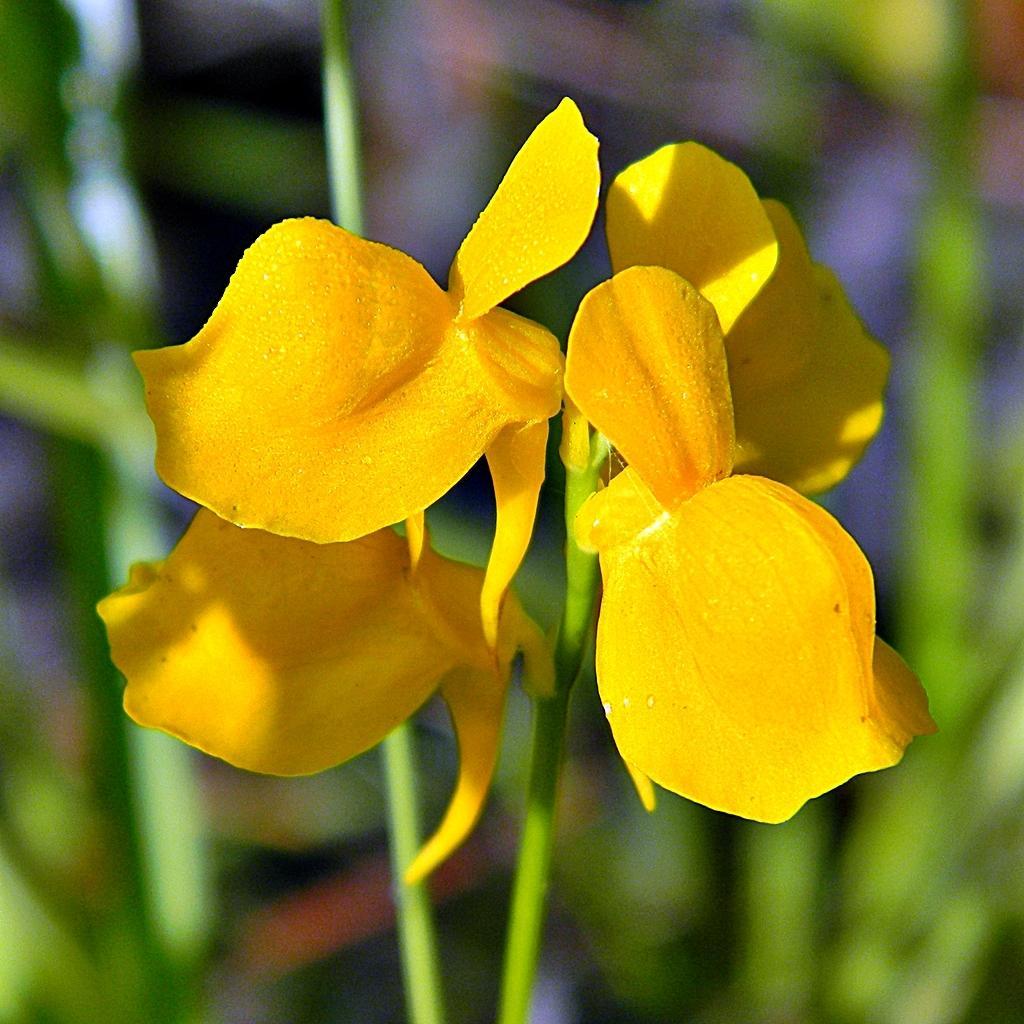Can you describe this image briefly? In this image I can see few yellow colour flower in the front and I can see this image is little bit blurry in the background. 